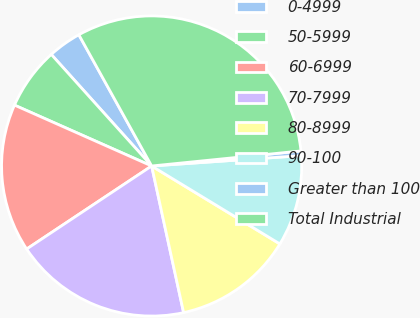Convert chart to OTSL. <chart><loc_0><loc_0><loc_500><loc_500><pie_chart><fcel>0-4999<fcel>50-5999<fcel>60-6999<fcel>70-7999<fcel>80-8999<fcel>90-100<fcel>Greater than 100<fcel>Total Industrial<nl><fcel>3.6%<fcel>6.69%<fcel>15.98%<fcel>19.08%<fcel>12.89%<fcel>9.79%<fcel>0.5%<fcel>31.46%<nl></chart> 